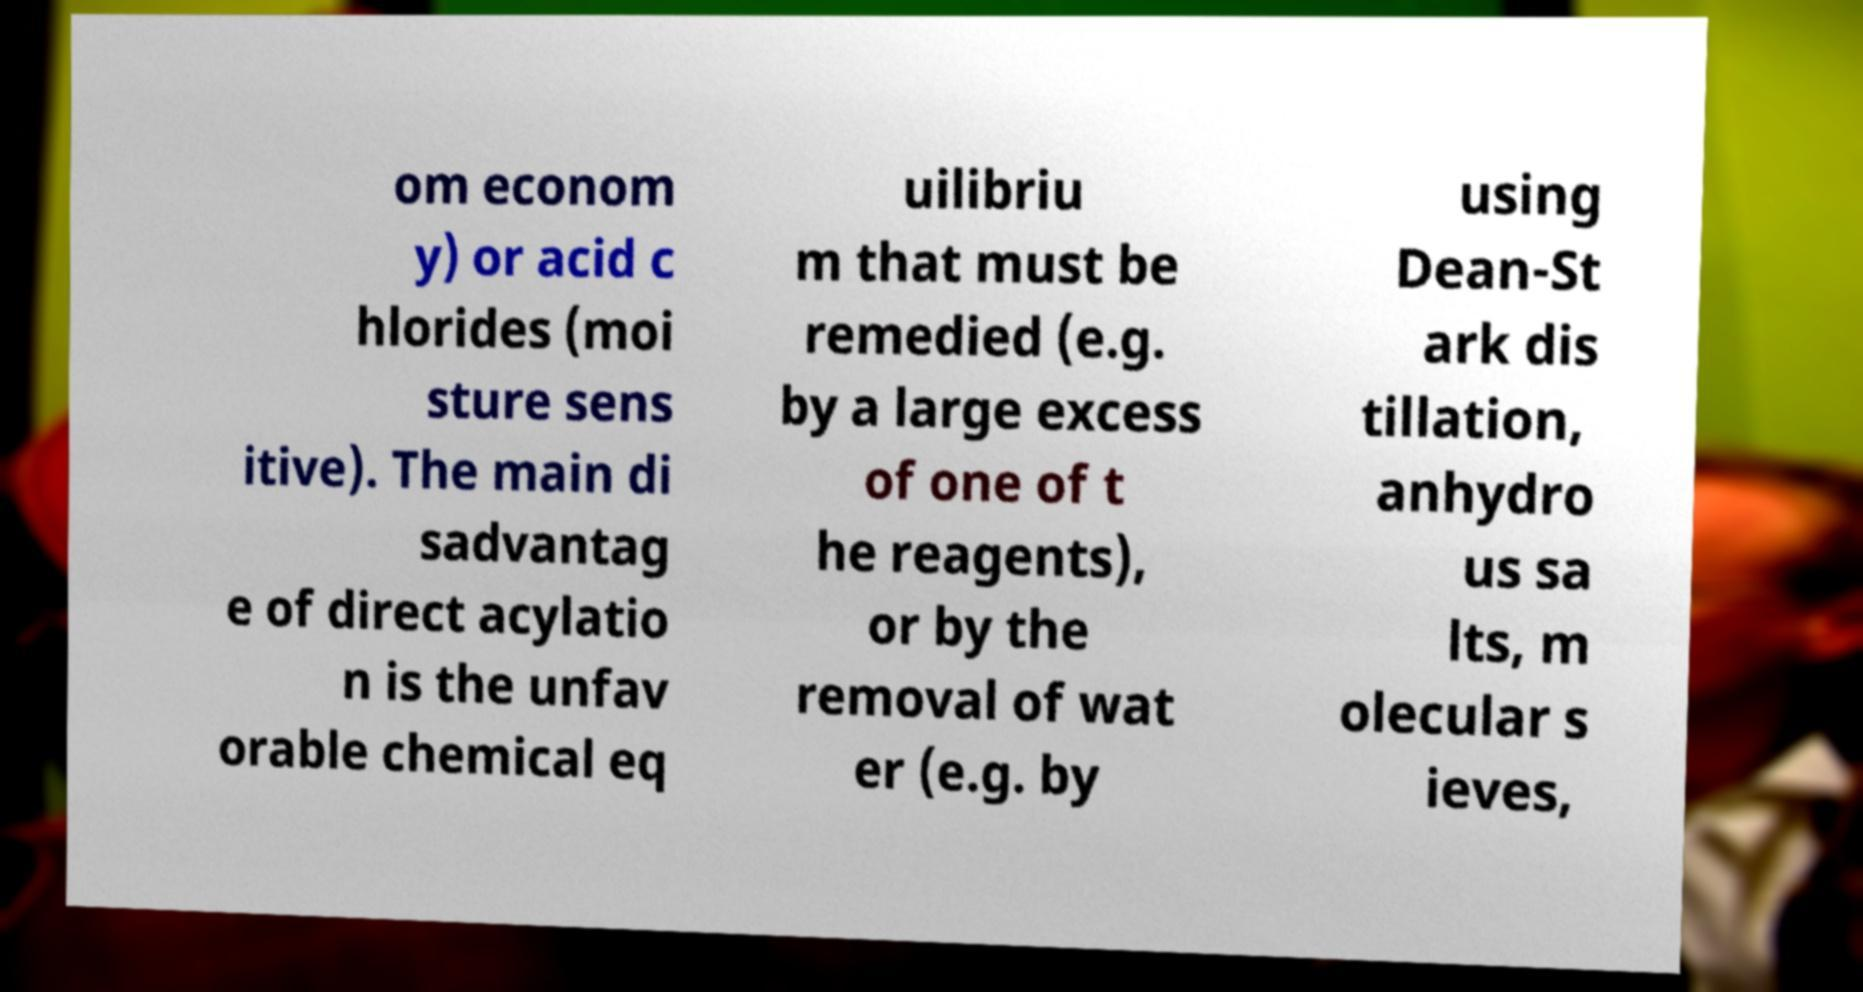Can you accurately transcribe the text from the provided image for me? om econom y) or acid c hlorides (moi sture sens itive). The main di sadvantag e of direct acylatio n is the unfav orable chemical eq uilibriu m that must be remedied (e.g. by a large excess of one of t he reagents), or by the removal of wat er (e.g. by using Dean-St ark dis tillation, anhydro us sa lts, m olecular s ieves, 